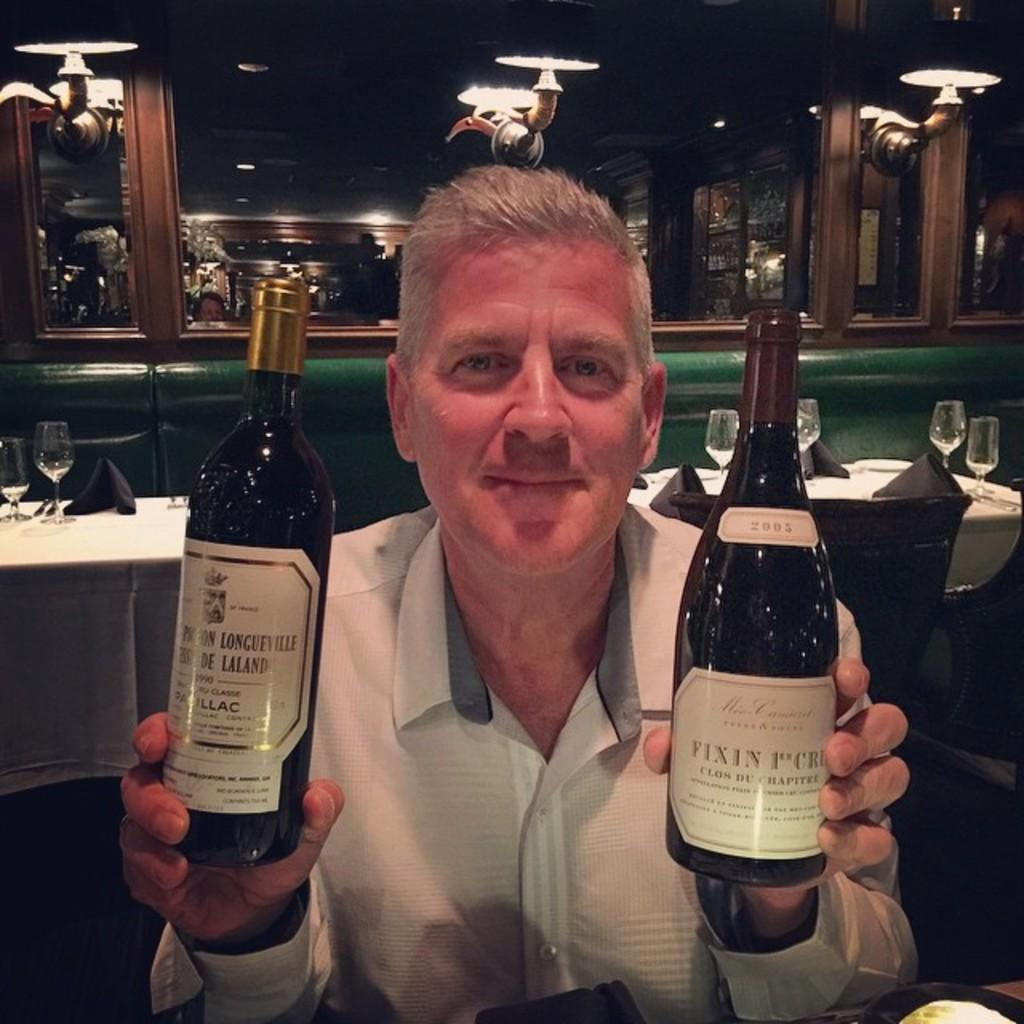Provide a one-sentence caption for the provided image. The bottle on the left is from the vintage 1990. 